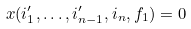<formula> <loc_0><loc_0><loc_500><loc_500>x ( i ^ { \prime } _ { 1 } , \dots , i ^ { \prime } _ { n - 1 } , i _ { n } , f _ { 1 } ) = 0</formula> 